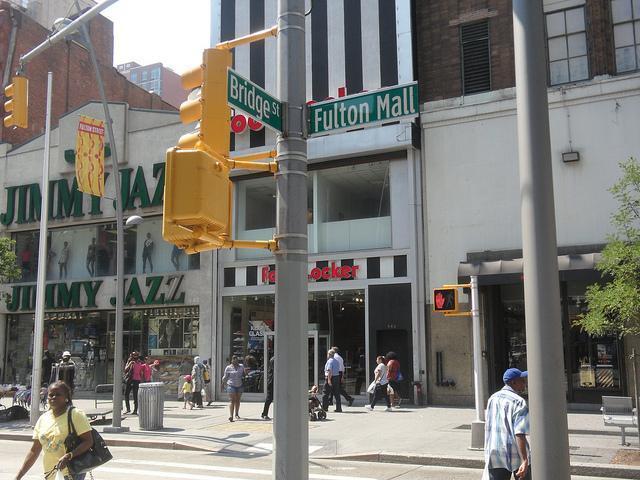How many people are there?
Give a very brief answer. 3. 